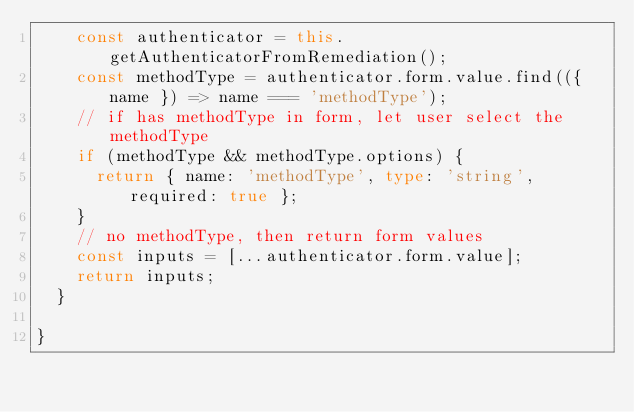Convert code to text. <code><loc_0><loc_0><loc_500><loc_500><_TypeScript_>    const authenticator = this.getAuthenticatorFromRemediation();
    const methodType = authenticator.form.value.find(({ name }) => name === 'methodType');
    // if has methodType in form, let user select the methodType
    if (methodType && methodType.options) {
      return { name: 'methodType', type: 'string', required: true };
    }
    // no methodType, then return form values
    const inputs = [...authenticator.form.value];
    return inputs;
  }

}
</code> 